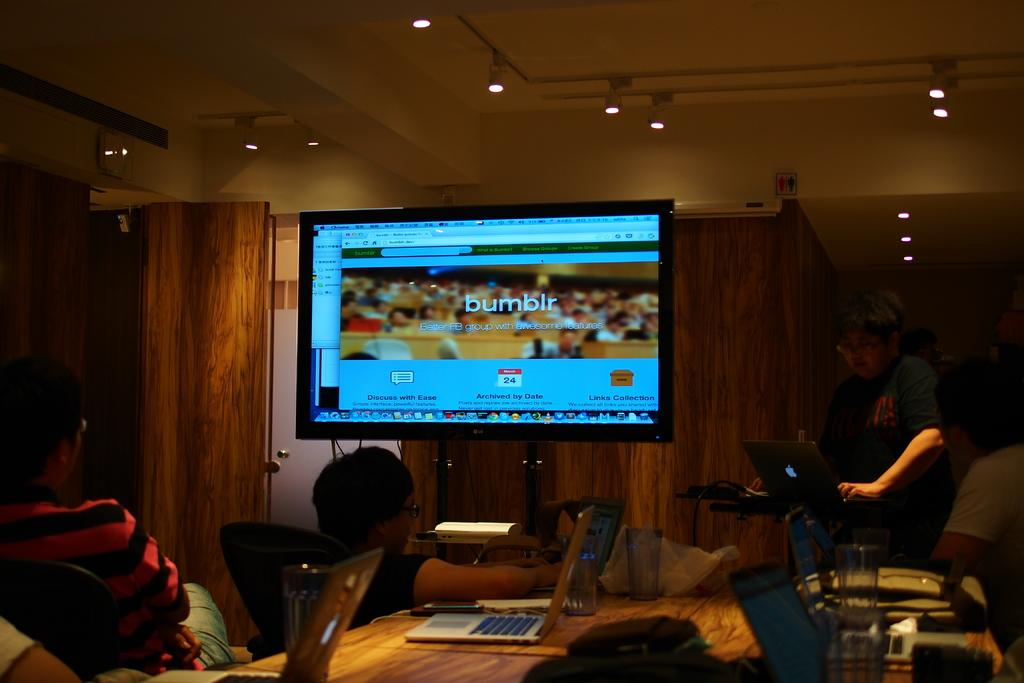Provide a one-sentence caption for the provided image. People on laptops at a conference table pay attention to a screen showing the Bumblr site. 